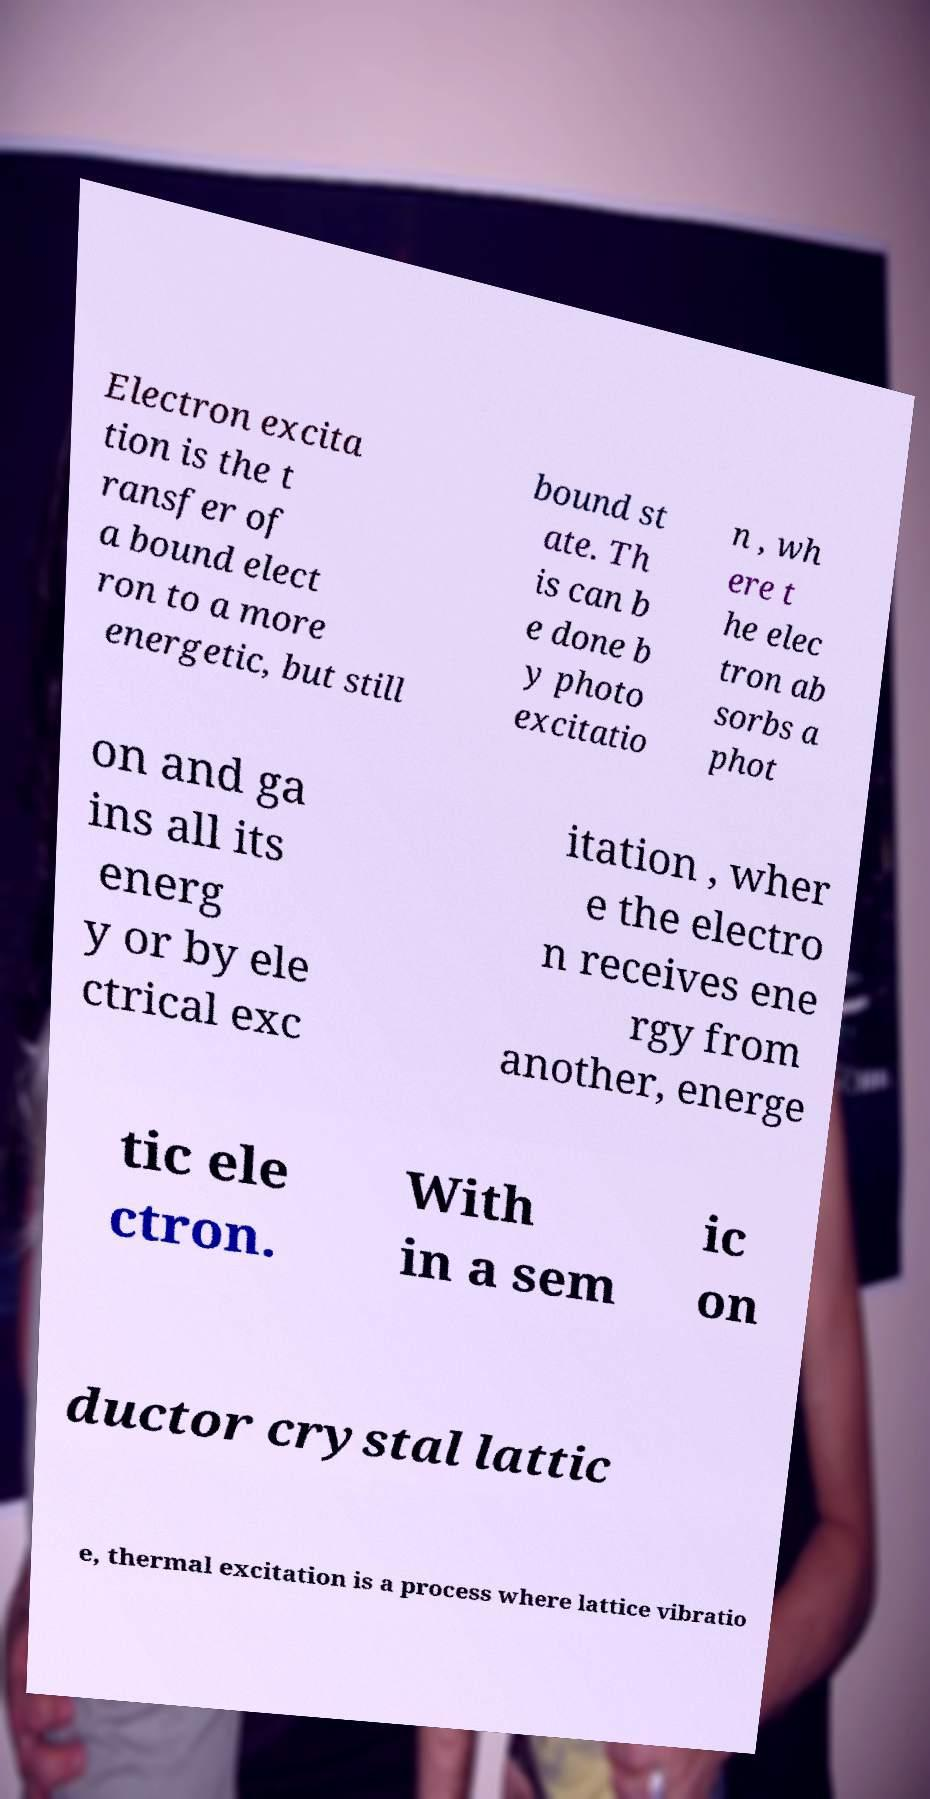For documentation purposes, I need the text within this image transcribed. Could you provide that? Electron excita tion is the t ransfer of a bound elect ron to a more energetic, but still bound st ate. Th is can b e done b y photo excitatio n , wh ere t he elec tron ab sorbs a phot on and ga ins all its energ y or by ele ctrical exc itation , wher e the electro n receives ene rgy from another, energe tic ele ctron. With in a sem ic on ductor crystal lattic e, thermal excitation is a process where lattice vibratio 